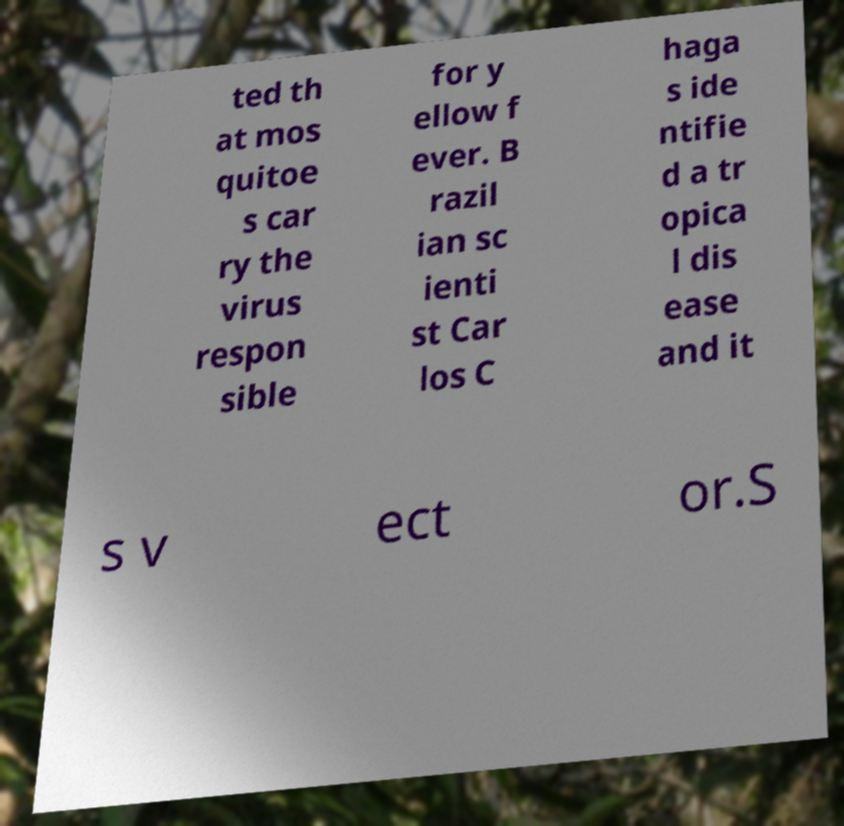Could you extract and type out the text from this image? ted th at mos quitoe s car ry the virus respon sible for y ellow f ever. B razil ian sc ienti st Car los C haga s ide ntifie d a tr opica l dis ease and it s v ect or.S 